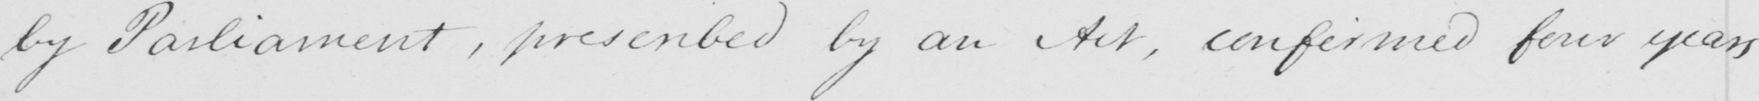What text is written in this handwritten line? by Parliament , prescribed by an Act , confirmed four years 